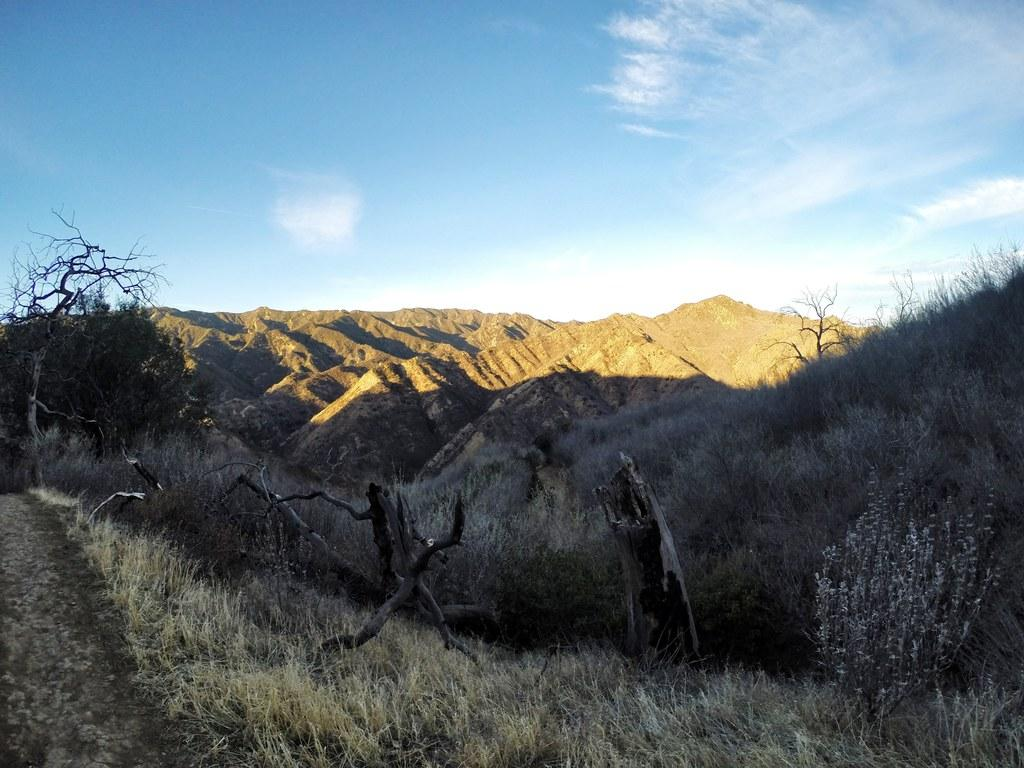What type of vegetation can be seen in the image? There is grass, plants, and trees in the image. What natural feature is visible in the background of the image? There is a mountain in the image. What part of the natural environment is visible in the image? The sky is visible in the image. What type of stocking is hanging from the tree in the image? There is no stocking hanging from the tree in the image; it only features grass, plants, trees, a mountain, and the sky. What kind of engine can be seen powering the mountain in the image? There is no engine present in the image, and the mountain is a natural feature. 